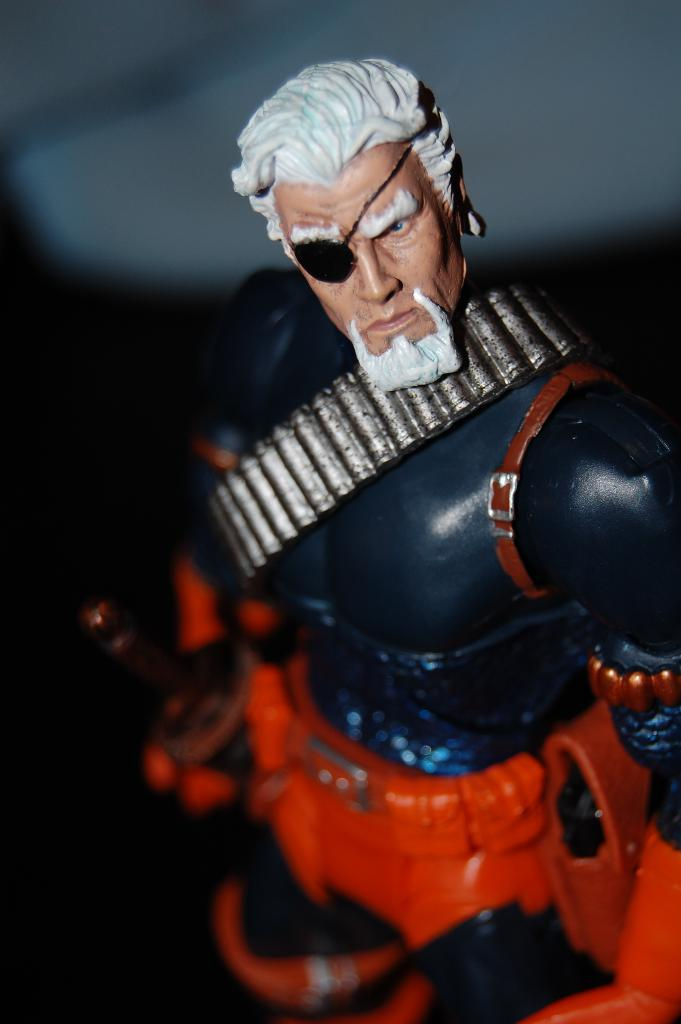What object in the image is designed for play or entertainment? There is a toy in the image. What type of mist can be seen surrounding the toy in the image? There is no mist present in the image; it only features a toy. 